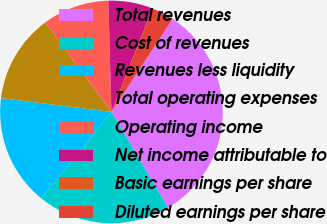Convert chart to OTSL. <chart><loc_0><loc_0><loc_500><loc_500><pie_chart><fcel>Total revenues<fcel>Cost of revenues<fcel>Revenues less liquidity<fcel>Total operating expenses<fcel>Operating income<fcel>Net income attributable to<fcel>Basic earnings per share<fcel>Diluted earnings per share<nl><fcel>32.25%<fcel>19.35%<fcel>16.13%<fcel>12.9%<fcel>9.68%<fcel>6.46%<fcel>0.01%<fcel>3.23%<nl></chart> 